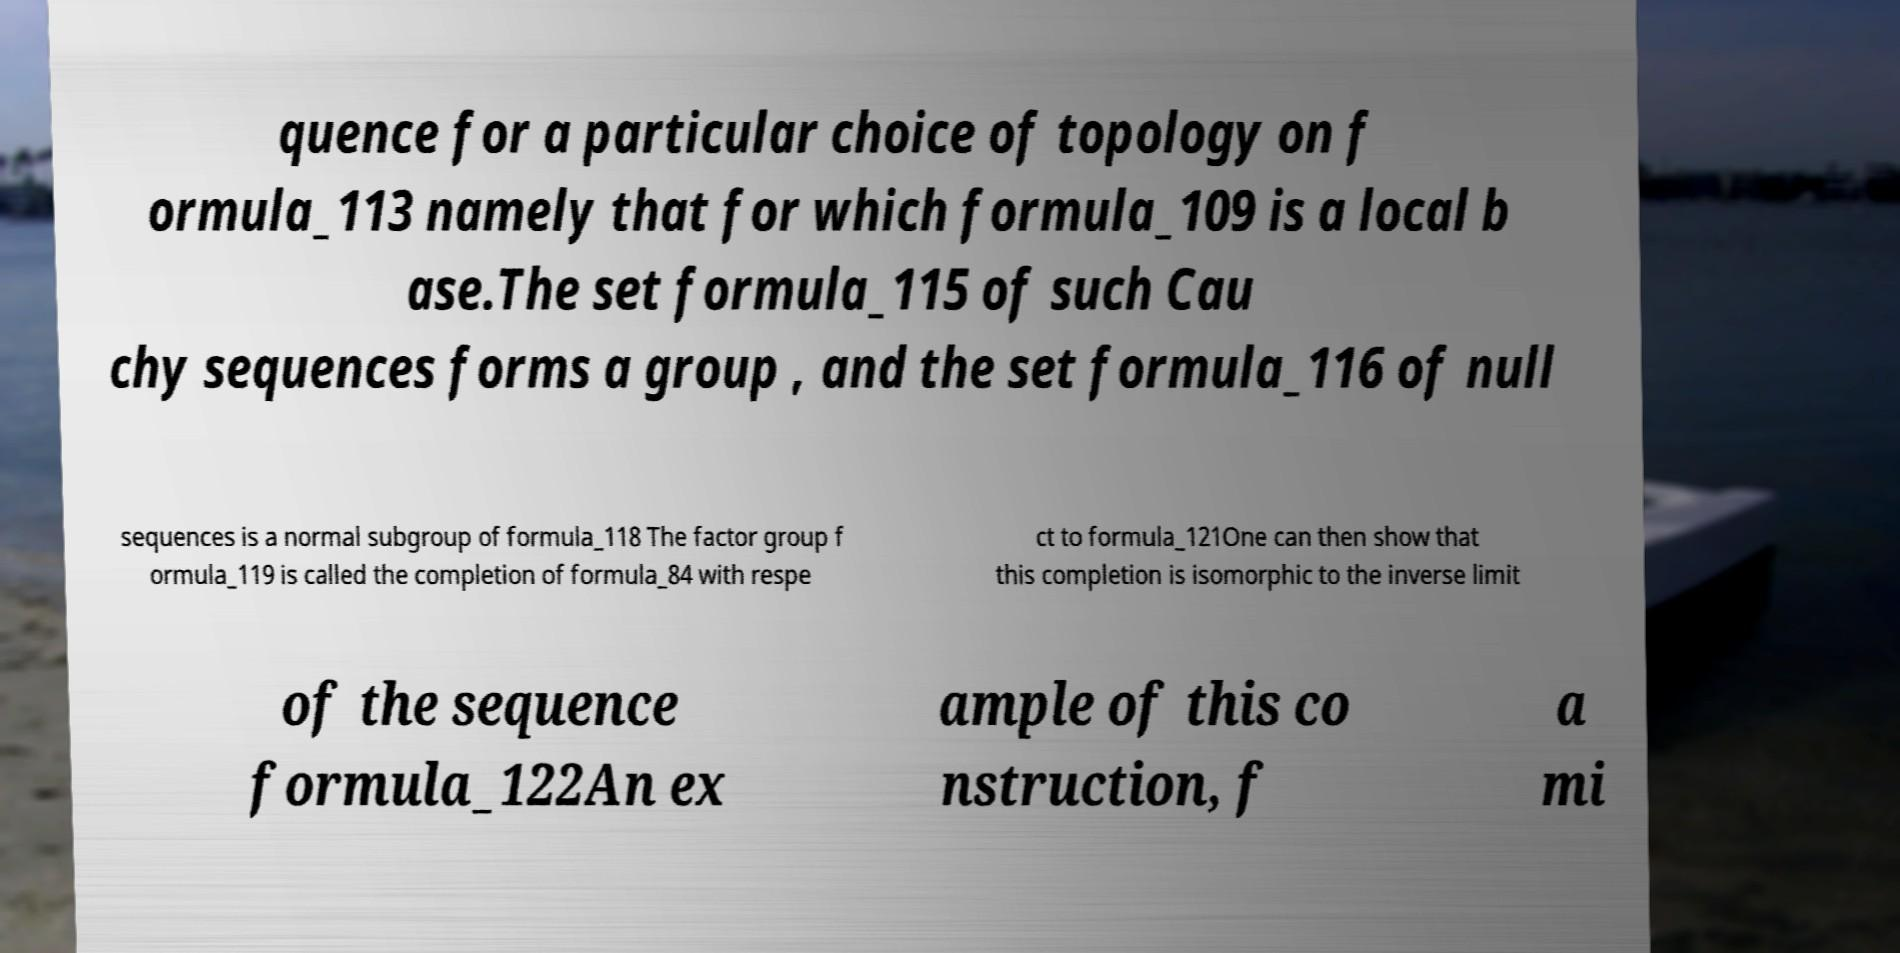For documentation purposes, I need the text within this image transcribed. Could you provide that? quence for a particular choice of topology on f ormula_113 namely that for which formula_109 is a local b ase.The set formula_115 of such Cau chy sequences forms a group , and the set formula_116 of null sequences is a normal subgroup of formula_118 The factor group f ormula_119 is called the completion of formula_84 with respe ct to formula_121One can then show that this completion is isomorphic to the inverse limit of the sequence formula_122An ex ample of this co nstruction, f a mi 